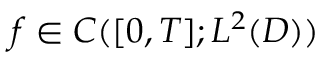Convert formula to latex. <formula><loc_0><loc_0><loc_500><loc_500>f \in C ( [ 0 , T ] ; L ^ { 2 } ( D ) )</formula> 